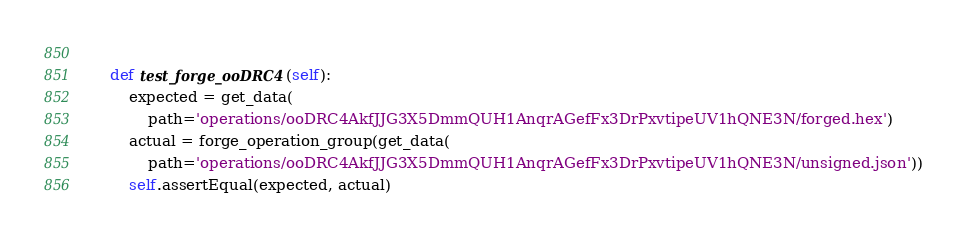Convert code to text. <code><loc_0><loc_0><loc_500><loc_500><_Python_>        
    def test_forge_ooDRC4(self):
        expected = get_data(
            path='operations/ooDRC4AkfJJG3X5DmmQUH1AnqrAGefFx3DrPxvtipeUV1hQNE3N/forged.hex')
        actual = forge_operation_group(get_data(
            path='operations/ooDRC4AkfJJG3X5DmmQUH1AnqrAGefFx3DrPxvtipeUV1hQNE3N/unsigned.json'))
        self.assertEqual(expected, actual)
</code> 